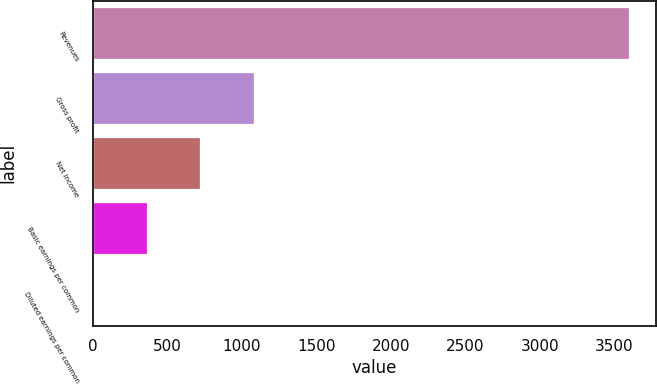<chart> <loc_0><loc_0><loc_500><loc_500><bar_chart><fcel>Revenues<fcel>Gross profit<fcel>Net income<fcel>Basic earnings per common<fcel>Diluted earnings per common<nl><fcel>3597.6<fcel>1080.06<fcel>720.41<fcel>360.76<fcel>1.11<nl></chart> 